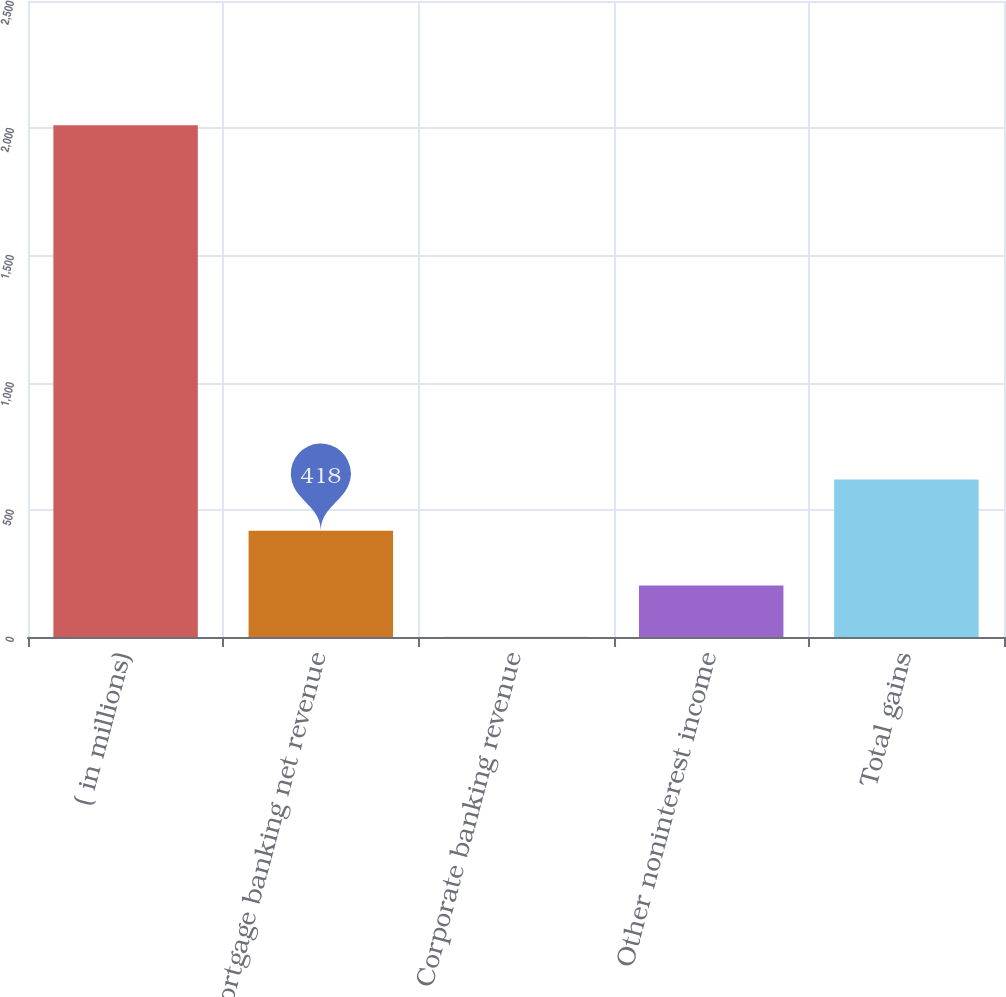Convert chart to OTSL. <chart><loc_0><loc_0><loc_500><loc_500><bar_chart><fcel>( in millions)<fcel>Mortgage banking net revenue<fcel>Corporate banking revenue<fcel>Other noninterest income<fcel>Total gains<nl><fcel>2012<fcel>418<fcel>1<fcel>202.1<fcel>619.1<nl></chart> 